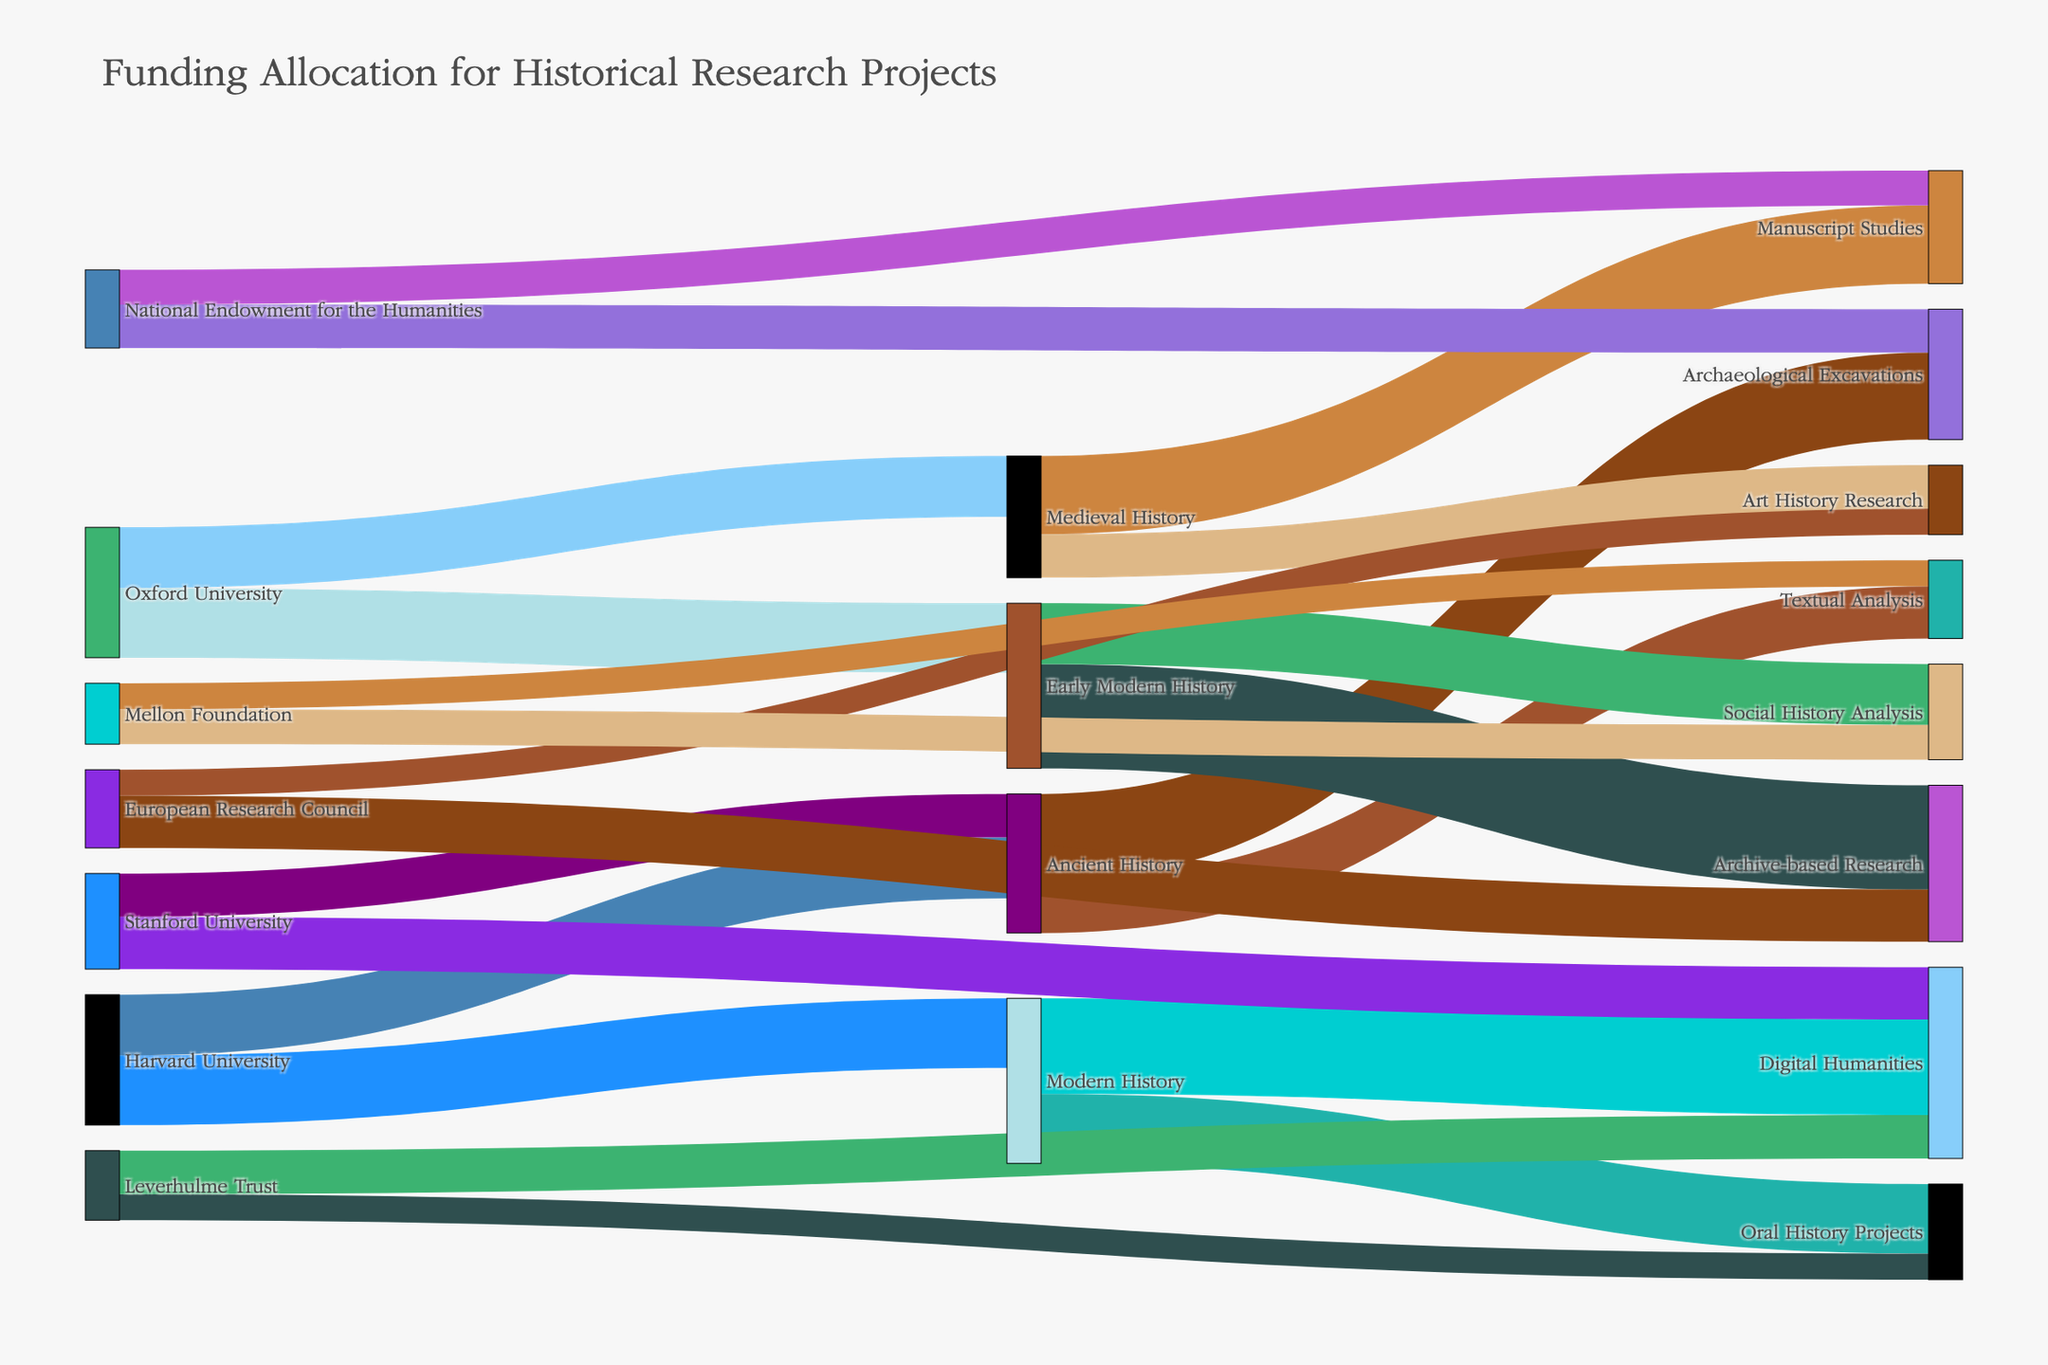what is the total funding allocation for Ancient History? To find the total funding for Ancient History, we sum up the values in the Sankey diagram for Ancient History. The values are split into Archaeological Excavations (5,000,000) and Textual Analysis (3,000,000). So, the sum is 5,000,000 + 3,000,000.
Answer: 8,000,000 Which institution allocated the most funding to historical research projects? We examine the various institutions and their total funding allocations in the Sankey diagram. Harvard University allocated 7,500,000 (Ancient History: 3,500,000 and Modern History: 4,000,000). Oxford University allocated 7,500,000 (Medieval History: 3,500,000 and Early Modern History: 4,000,000). Stanford University allocated 5,500,000 (Ancient History: 2,500,000 and Digital Humanities: 3,000,000). The National Endowment for the Humanities allocated 4,500,000 (Archaeological Excavations: 2,500,000 and Manuscript Studies: 2,000,000). The European Research Council allocated 4,500,000 (Archive-based Research: 3,000,000 and Art History Research: 1,500,000). The Mellon Foundation allocated 3,500,000 (Textual Analysis: 1,500,000 and Social History Analysis: 2,000,000). Leverhulme Trust allocated 4,000,000 (Oral History Projects: 1,500,000 and Digital Humanities: 2,500,000). Therefore, both Harvard University and Oxford University allocated the most funding.
Answer: Harvard University and Oxford University Which research methodology received the least funding? By examining the diagram's links from vague memory, we observe the connections and their respective values. Art History Research, connected to Medieval History with 2,500,000, is less than the accumulated funding of others.
Answer: Art History Research How much funding did Oxford University allocate for Early Modern History? From the Sankey diagram, find Oxford University's node and trace its link to Early Modern History. The value is 4,000,000.
Answer: 4,000,000 What are the two primary sources of funding for Digital Humanities? Follow the links leading to Digital Humanities in the diagram. Leverhulme Trust and Stanford University are connected with 2,500,000 and 3,000,000, respectively.
Answer: Leverhulme Trust and Stanford University What is the combined funding for Archival-based Research and Oral History Projects? To arrive at the total funding, add the value for Archival-based Research (6,000,000 from Early Modern History) and Oral History Projects (4,000,000 from Modern History). The sum is 6,000,000 + 4,000,000.
Answer: 10,000,000 Compare the funding allocated to Modern History by Harvard University and the funding allocated by Leverhulme Trust to Digital Humanities. Harvard University’s link to Modern History shows 4,000,000. Leverhulme Trust links to Digital Humanities with 2,500,000. Comparing these figures, Harvard University allocated more.
Answer: Harvard University allocated more How did Mellon Foundation divide its funding between Textual Analysis and Social History Analysis? The diagram indicates that Mellon Foundation links to Textual Analysis with 1,500,000 and Social History Analysis with 2,000,000. To check the allocation, compare and state these two values.
Answer: Textual Analysis: 1,500,000, Social History Analysis: 2,000,000 Which historical period received the highest total funding allocation across all methodologies and institutions? Summing up the allocated funding for each historical period (Ancient: 8,000,000; Medieval: 7,000,000; Early Modern: 9,500,000; Modern: 9,500,000), Early Modern and Modern History received the highest.
Answer: Early Modern History and Modern History 